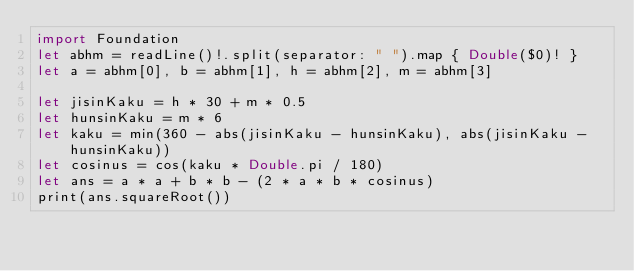Convert code to text. <code><loc_0><loc_0><loc_500><loc_500><_Swift_>import Foundation
let abhm = readLine()!.split(separator: " ").map { Double($0)! }
let a = abhm[0], b = abhm[1], h = abhm[2], m = abhm[3]

let jisinKaku = h * 30 + m * 0.5
let hunsinKaku = m * 6
let kaku = min(360 - abs(jisinKaku - hunsinKaku), abs(jisinKaku - hunsinKaku))
let cosinus = cos(kaku * Double.pi / 180)
let ans = a * a + b * b - (2 * a * b * cosinus)
print(ans.squareRoot())</code> 